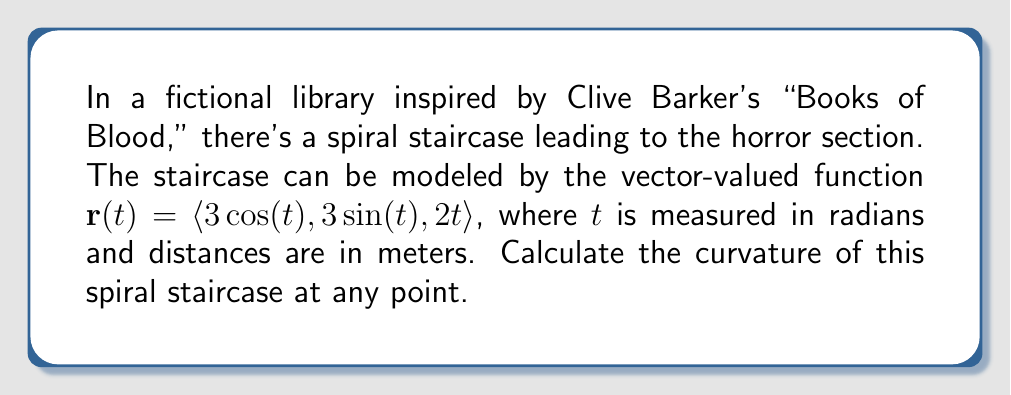Give your solution to this math problem. To find the curvature of the spiral staircase, we'll use the formula for the curvature of a space curve:

$$\kappa = \frac{|\mathbf{r}'(t) \times \mathbf{r}''(t)|}{|\mathbf{r}'(t)|^3}$$

Step 1: Calculate $\mathbf{r}'(t)$
$$\mathbf{r}'(t) = \langle -3\sin(t), 3\cos(t), 2 \rangle$$

Step 2: Calculate $\mathbf{r}''(t)$
$$\mathbf{r}''(t) = \langle -3\cos(t), -3\sin(t), 0 \rangle$$

Step 3: Calculate $\mathbf{r}'(t) \times \mathbf{r}''(t)$
$$\begin{align*}
\mathbf{r}'(t) \times \mathbf{r}''(t) &= \begin{vmatrix} 
\mathbf{i} & \mathbf{j} & \mathbf{k} \\
-3\sin(t) & 3\cos(t) & 2 \\
-3\cos(t) & -3\sin(t) & 0
\end{vmatrix} \\
&= \langle -6\sin(t), -6\cos(t), -9\sin^2(t) - 9\cos^2(t) \rangle \\
&= \langle -6\sin(t), -6\cos(t), -9 \rangle
\end{align*}$$

Step 4: Calculate $|\mathbf{r}'(t) \times \mathbf{r}''(t)|$
$$|\mathbf{r}'(t) \times \mathbf{r}''(t)| = \sqrt{36\sin^2(t) + 36\cos^2(t) + 81} = \sqrt{117} = 3\sqrt{13}$$

Step 5: Calculate $|\mathbf{r}'(t)|$
$$|\mathbf{r}'(t)| = \sqrt{9\sin^2(t) + 9\cos^2(t) + 4} = \sqrt{13}$$

Step 6: Calculate $|\mathbf{r}'(t)|^3$
$$|\mathbf{r}'(t)|^3 = (\sqrt{13})^3 = 13\sqrt{13}$$

Step 7: Apply the curvature formula
$$\kappa = \frac{|\mathbf{r}'(t) \times \mathbf{r}''(t)|}{|\mathbf{r}'(t)|^3} = \frac{3\sqrt{13}}{13\sqrt{13}} = \frac{3}{13}$$

The curvature is constant and doesn't depend on $t$, which means the spiral staircase has the same curvature at every point.
Answer: The curvature of the spiral staircase is $\frac{3}{13}$ at any point. 